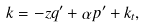Convert formula to latex. <formula><loc_0><loc_0><loc_500><loc_500>k = - z q ^ { \prime } + \alpha p ^ { \prime } + k _ { t } ,</formula> 